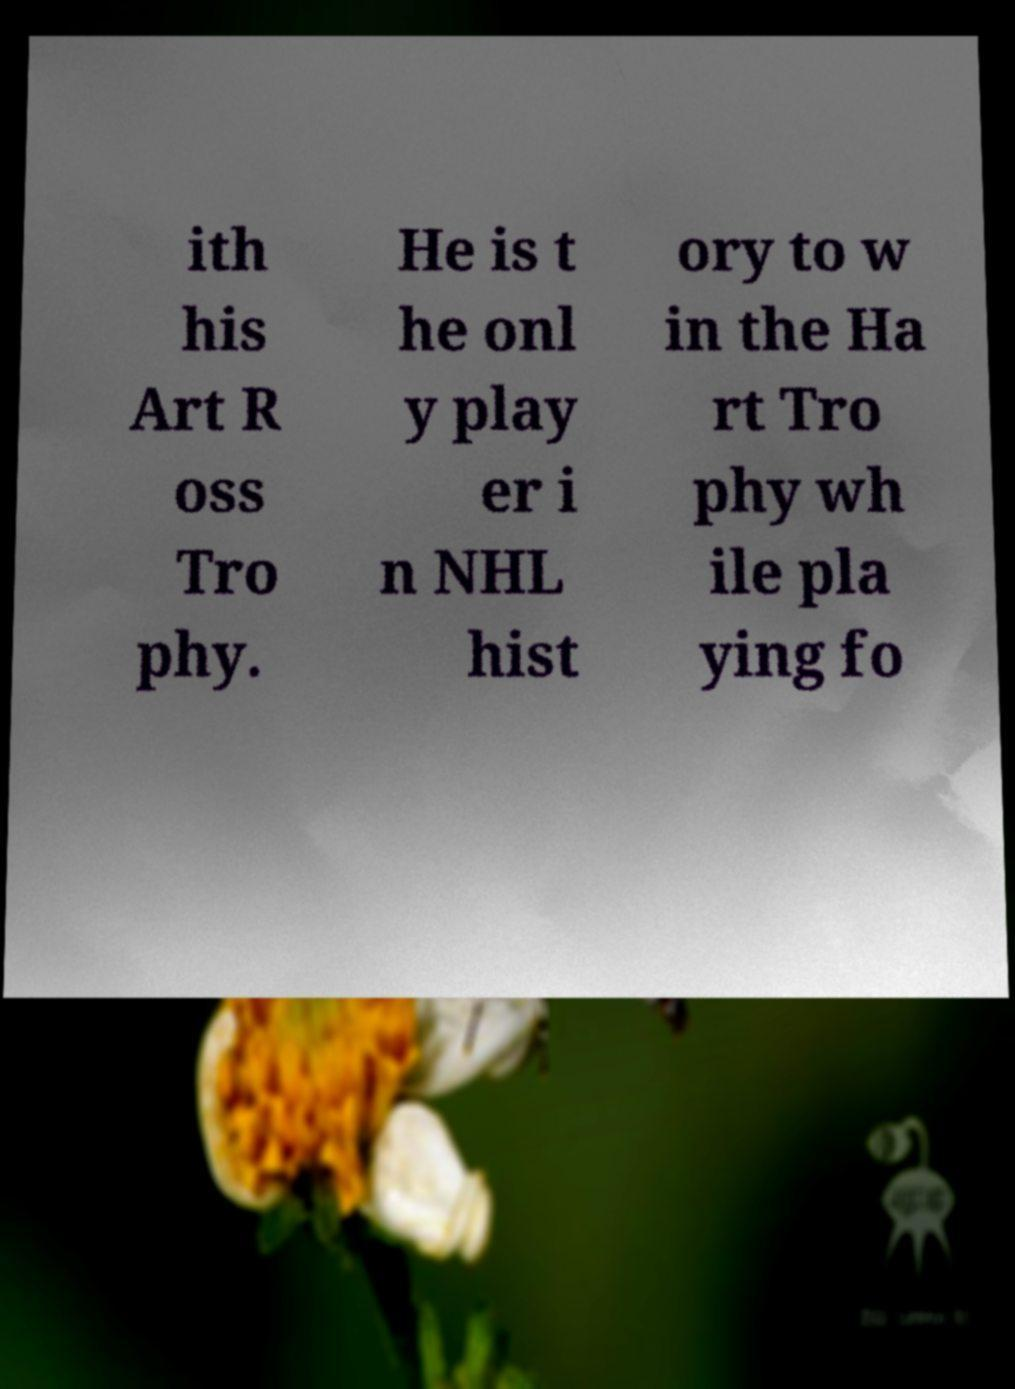I need the written content from this picture converted into text. Can you do that? ith his Art R oss Tro phy. He is t he onl y play er i n NHL hist ory to w in the Ha rt Tro phy wh ile pla ying fo 